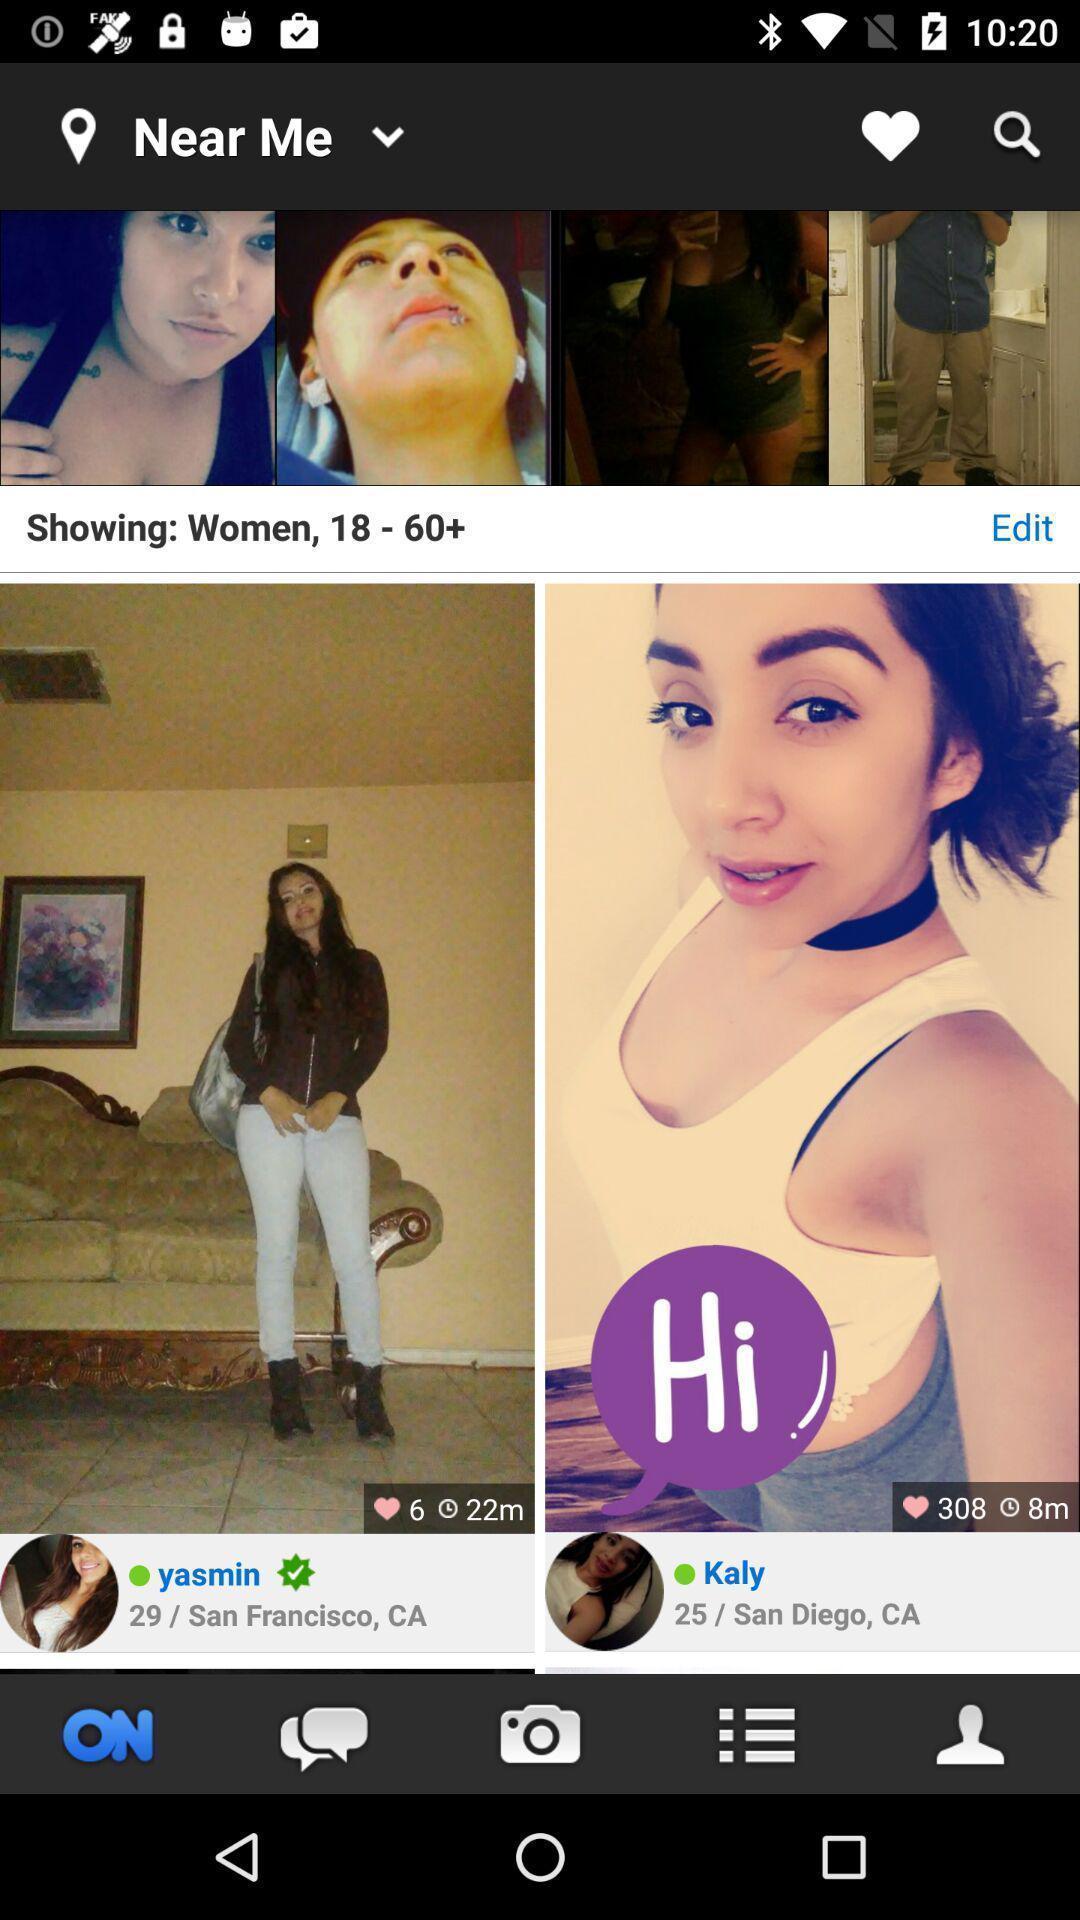Provide a textual representation of this image. Page showing the list image in a social app. 